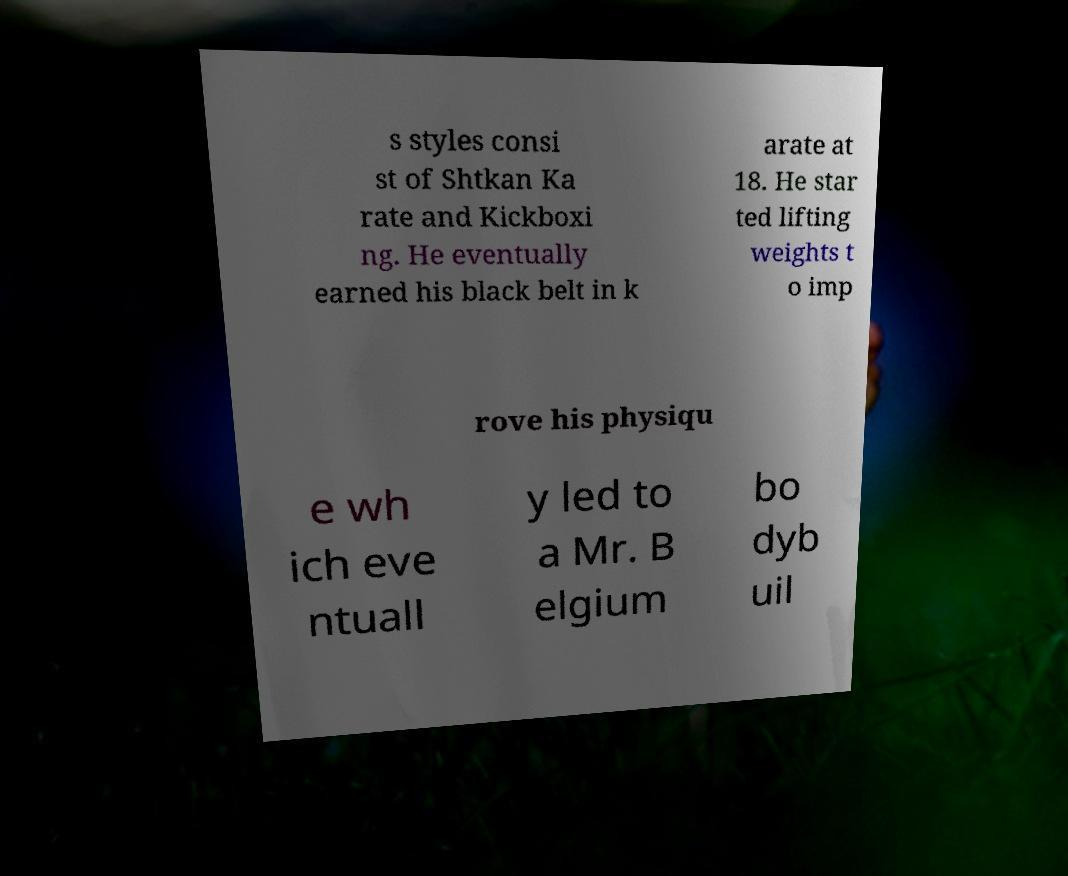There's text embedded in this image that I need extracted. Can you transcribe it verbatim? s styles consi st of Shtkan Ka rate and Kickboxi ng. He eventually earned his black belt in k arate at 18. He star ted lifting weights t o imp rove his physiqu e wh ich eve ntuall y led to a Mr. B elgium bo dyb uil 